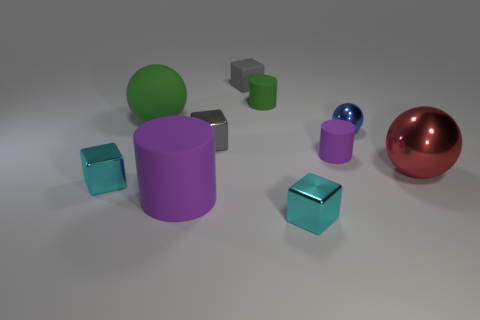Are there any small matte things of the same color as the big matte cylinder?
Offer a very short reply. Yes. Are there any large purple blocks that have the same material as the tiny green cylinder?
Ensure brevity in your answer.  No. There is a big object that is both left of the blue object and in front of the tiny blue sphere; what is its shape?
Your answer should be compact. Cylinder. How many big objects are either blue balls or gray metal cubes?
Provide a short and direct response. 0. What is the material of the small blue object?
Offer a terse response. Metal. What number of other things are there of the same shape as the red object?
Your answer should be compact. 2. What is the size of the green sphere?
Your answer should be very brief. Large. There is a matte thing that is both on the left side of the gray matte object and behind the big cylinder; how big is it?
Your response must be concise. Large. There is a shiny thing on the right side of the small blue metallic ball; what is its shape?
Keep it short and to the point. Sphere. Does the blue ball have the same material as the gray thing in front of the blue metal object?
Provide a succinct answer. Yes. 